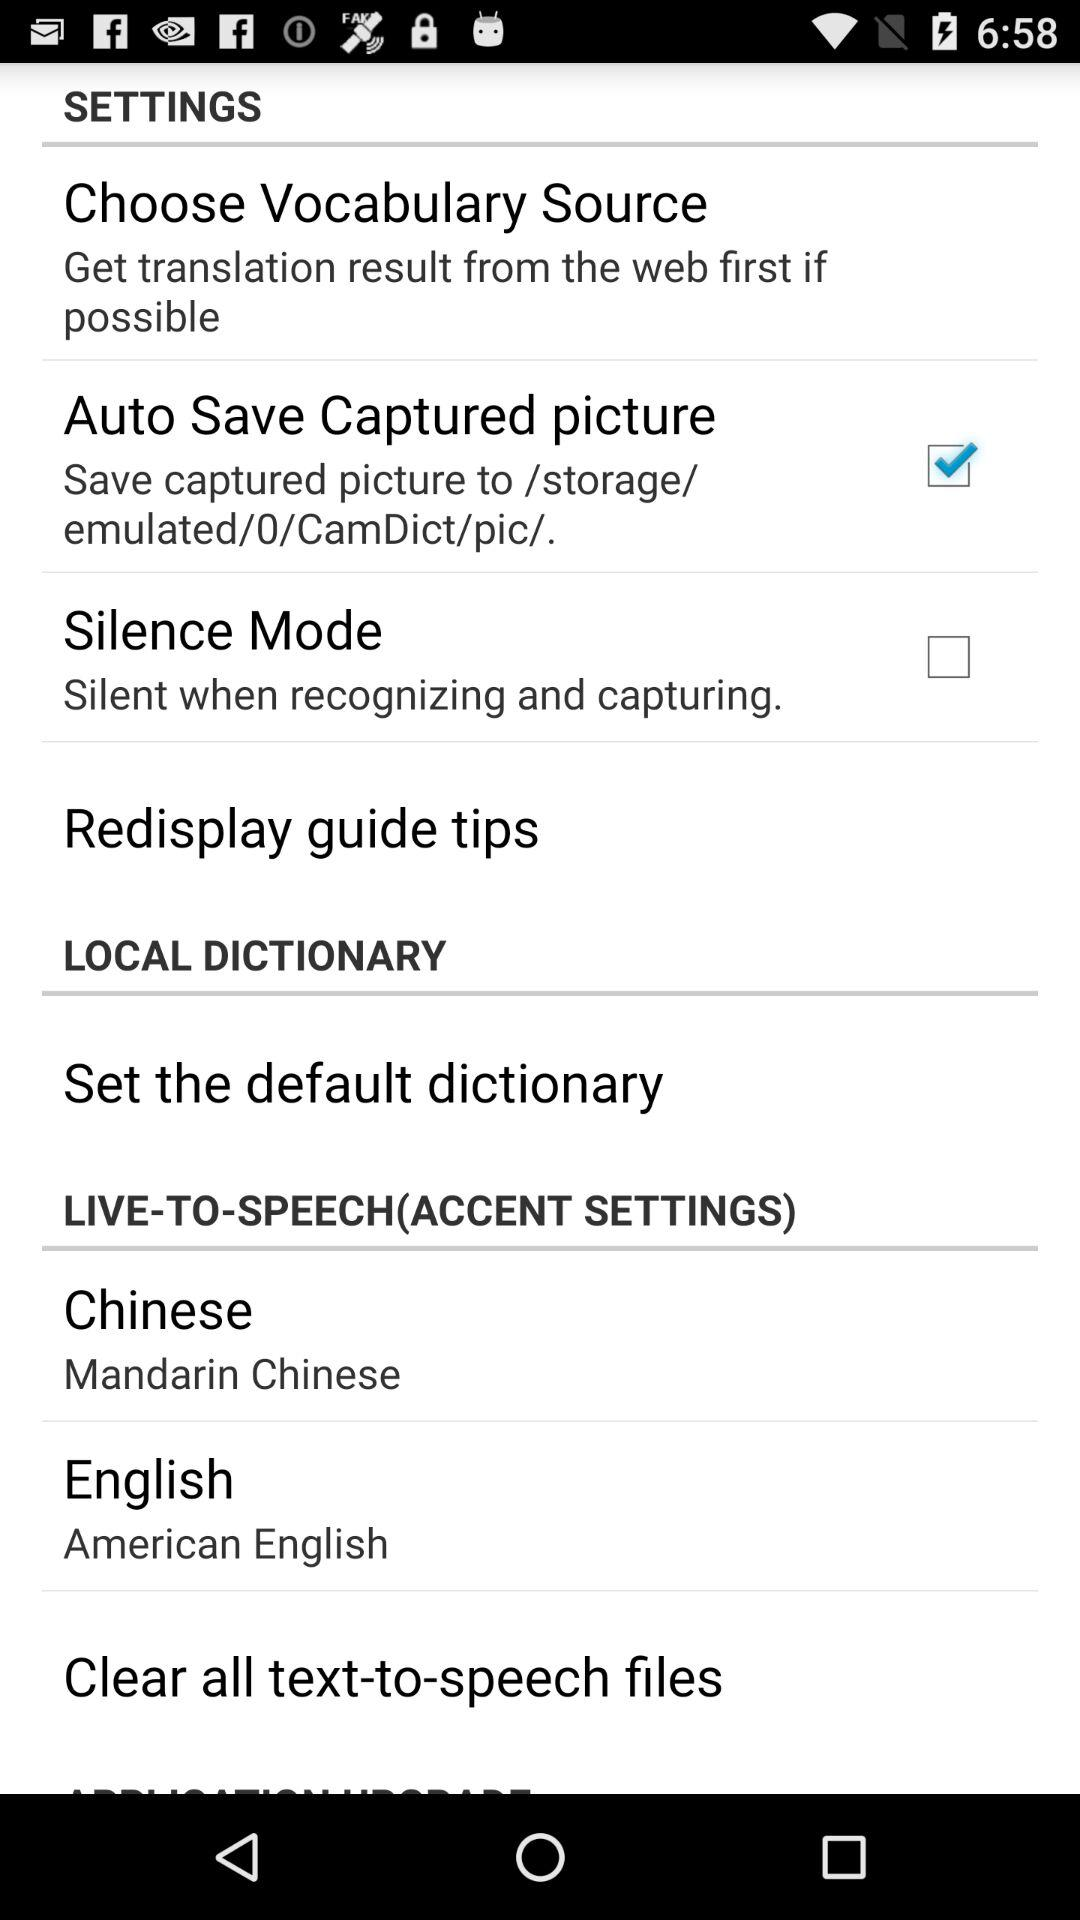What is the status of "Auto Save Captured picture"? The status is "on". 